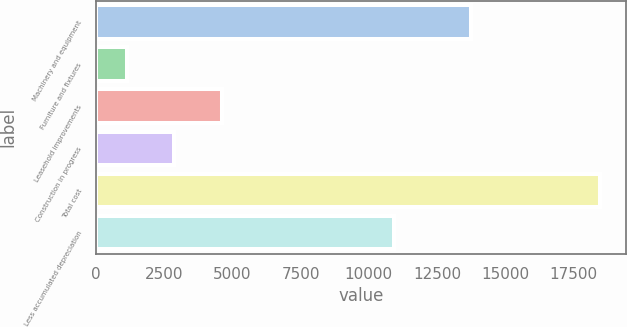Convert chart to OTSL. <chart><loc_0><loc_0><loc_500><loc_500><bar_chart><fcel>Machinery and equipment<fcel>Furniture and fixtures<fcel>Leasehold improvements<fcel>Construction in progress<fcel>Total cost<fcel>Less accumulated depreciation<nl><fcel>13758<fcel>1130<fcel>4601.8<fcel>2865.9<fcel>18489<fcel>10938<nl></chart> 